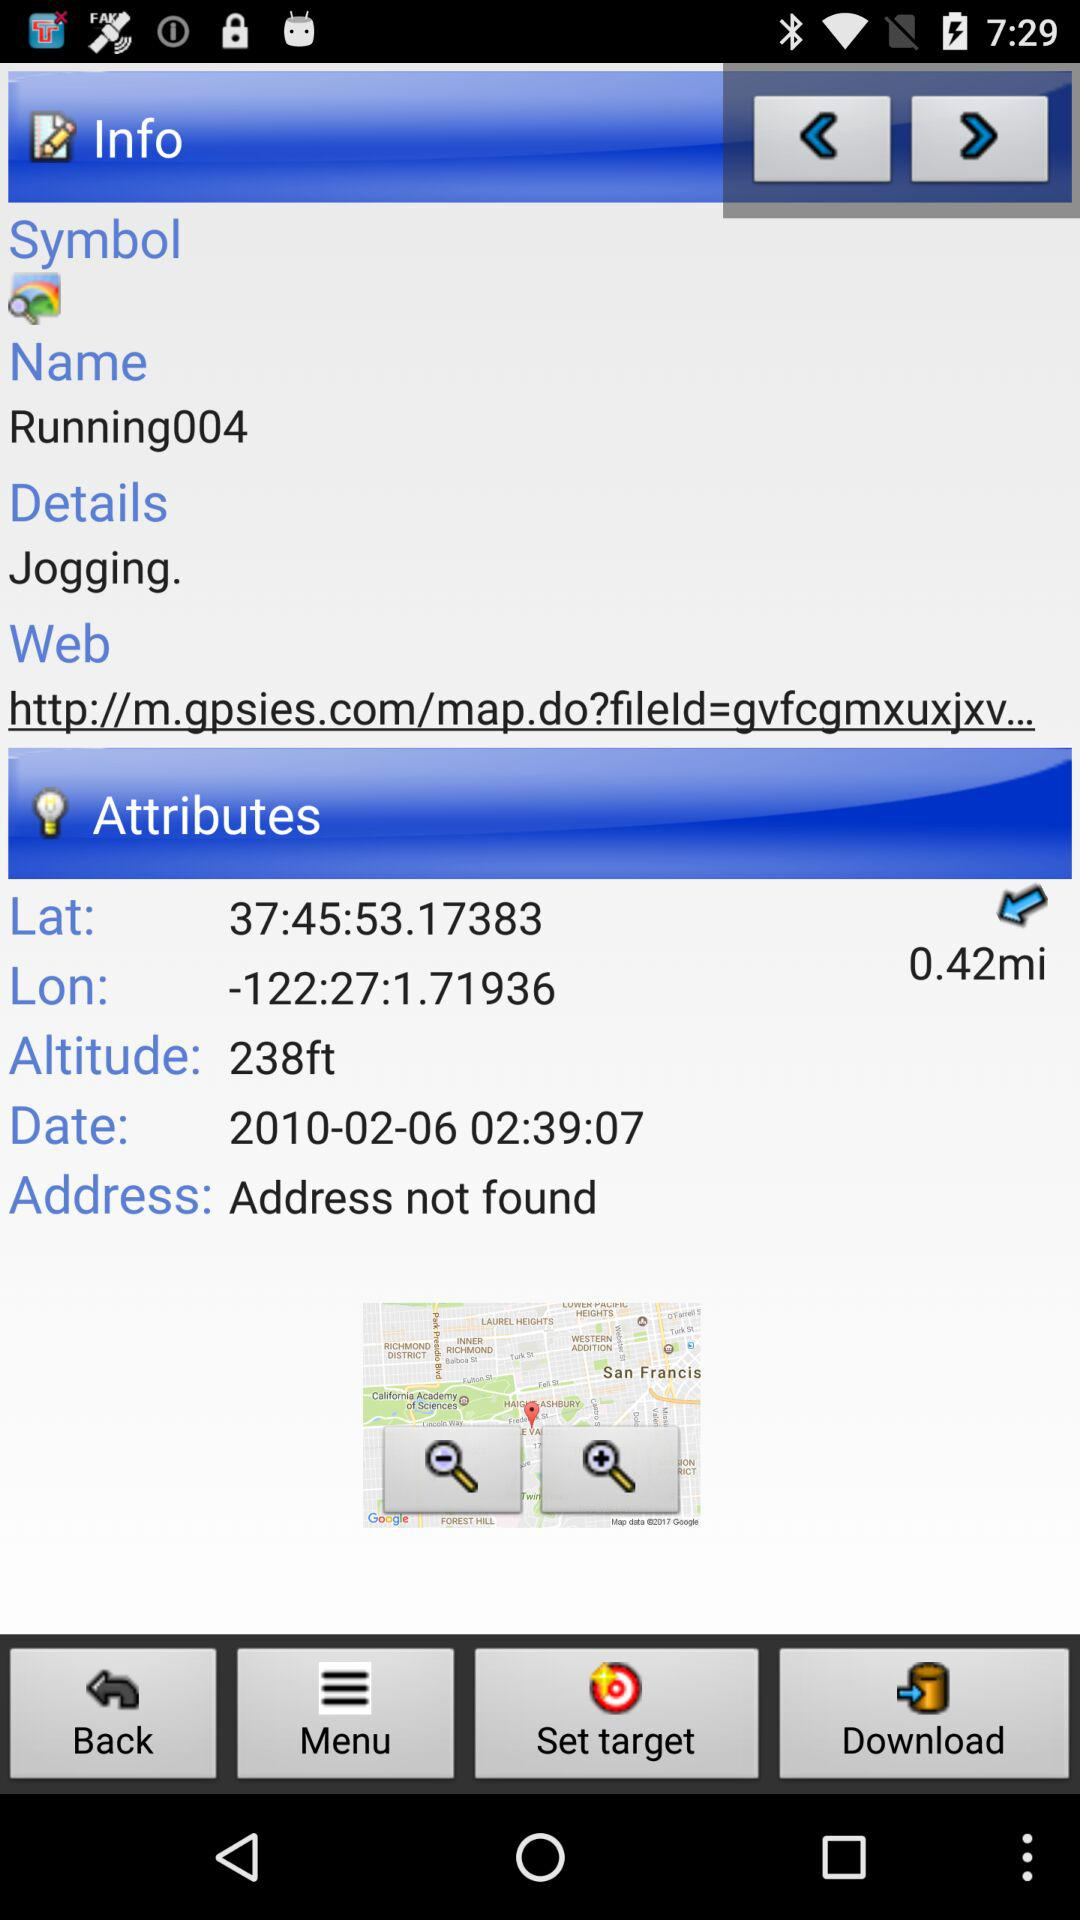What are the latitude and longitude numbers? The latitude and longitude numbers are 37:45:53.17383 and -122:27:1.71936, respectively. 